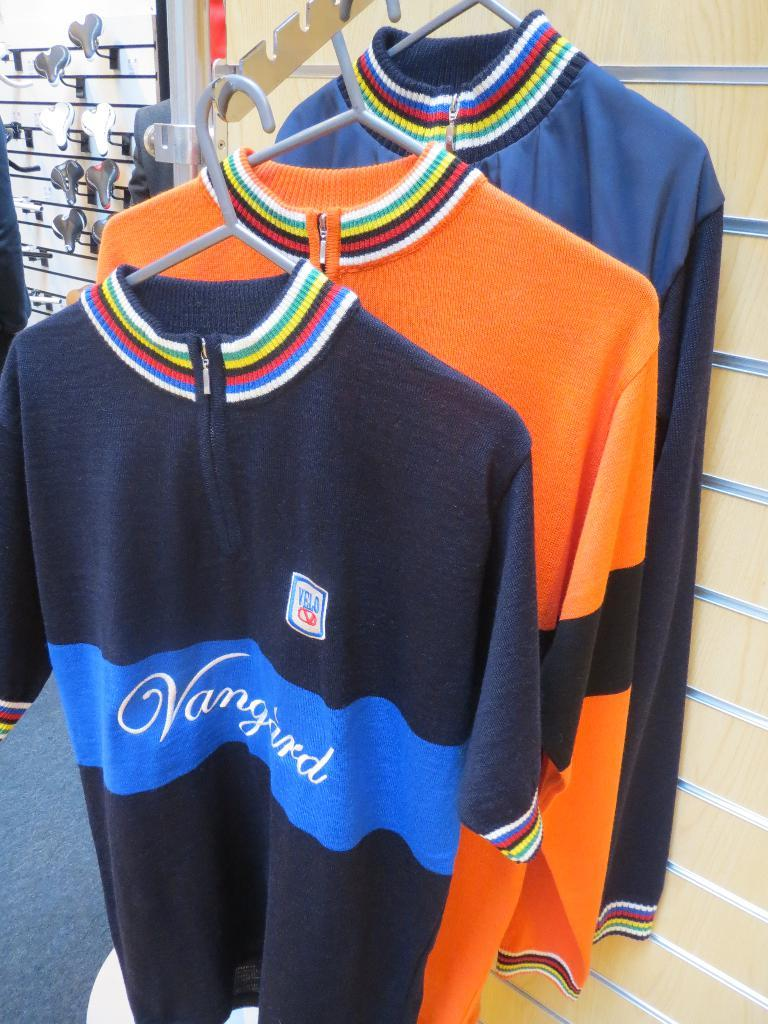Provide a one-sentence caption for the provided image. The sweaters on display in a store have the name Vangard. 